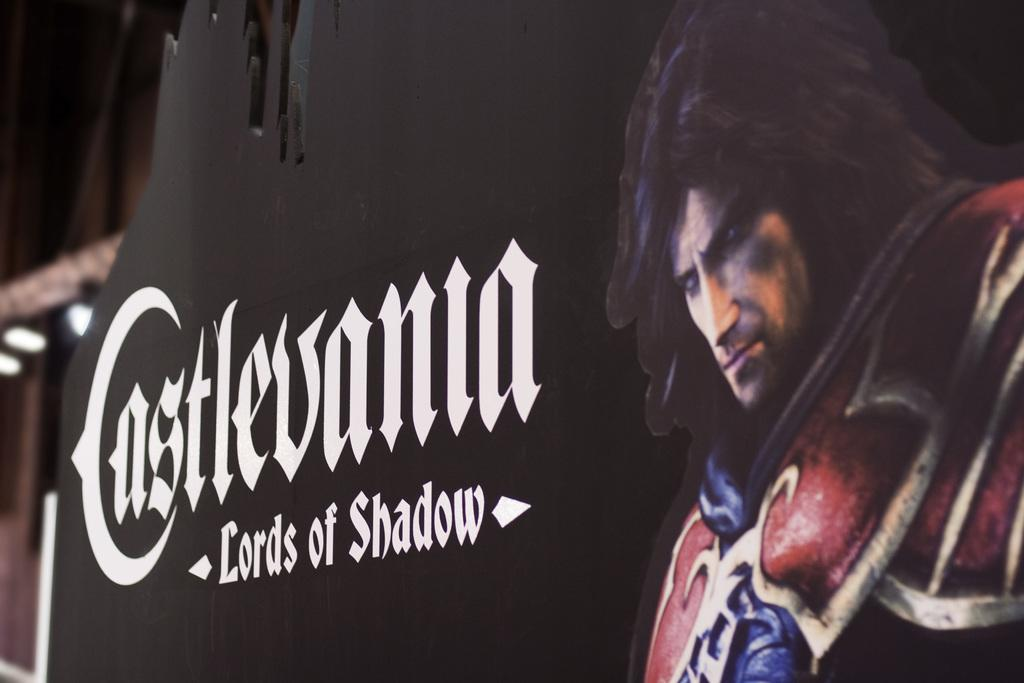What is the primary feature of the image? There is a black frame in the image. What else can be seen within the black frame? There is text and an image of a person in the image. How does the nerve affect the image? There is no mention of a nerve in the image or the provided facts, so it cannot be determined how a nerve would affect the image. 